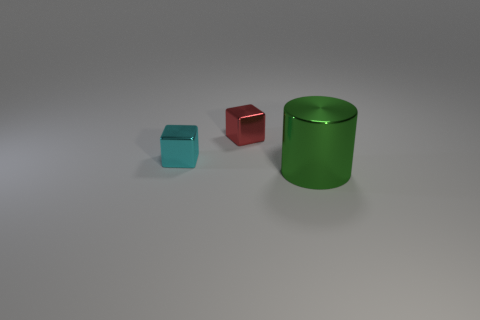Can you tell me what other shapes and colors are present besides the large green cylinder? Beyond the large green cylinder, there are two cubes in the image: one is smaller and turquoise, and the other is medium-sized and red. Both cubes are to the left of the cylinder and are also illuminated softly by the ambient light. 